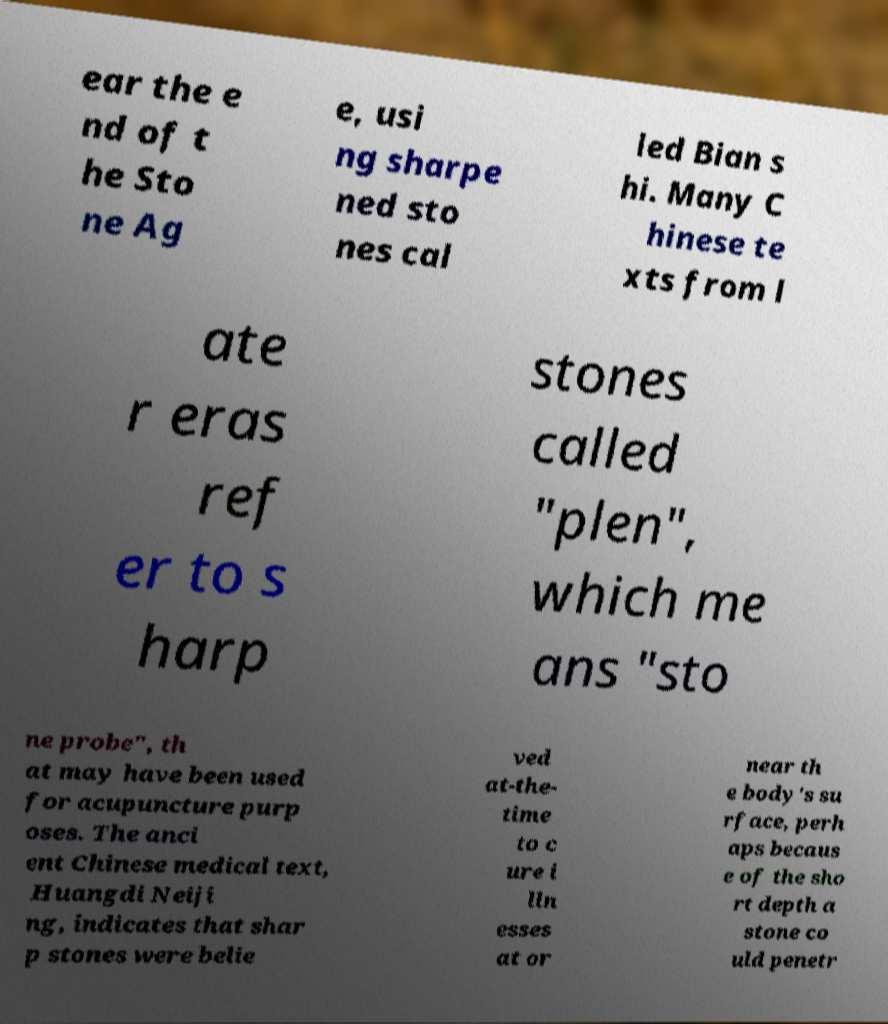There's text embedded in this image that I need extracted. Can you transcribe it verbatim? ear the e nd of t he Sto ne Ag e, usi ng sharpe ned sto nes cal led Bian s hi. Many C hinese te xts from l ate r eras ref er to s harp stones called "plen", which me ans "sto ne probe", th at may have been used for acupuncture purp oses. The anci ent Chinese medical text, Huangdi Neiji ng, indicates that shar p stones were belie ved at-the- time to c ure i lln esses at or near th e body's su rface, perh aps becaus e of the sho rt depth a stone co uld penetr 